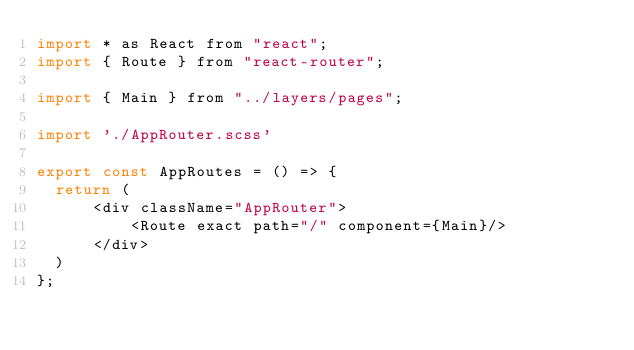<code> <loc_0><loc_0><loc_500><loc_500><_JavaScript_>import * as React from "react";
import { Route } from "react-router";

import { Main } from "../layers/pages";

import './AppRouter.scss'

export const AppRoutes = () => {
  return (
      <div className="AppRouter">
          <Route exact path="/" component={Main}/>
      </div>
  )
};</code> 